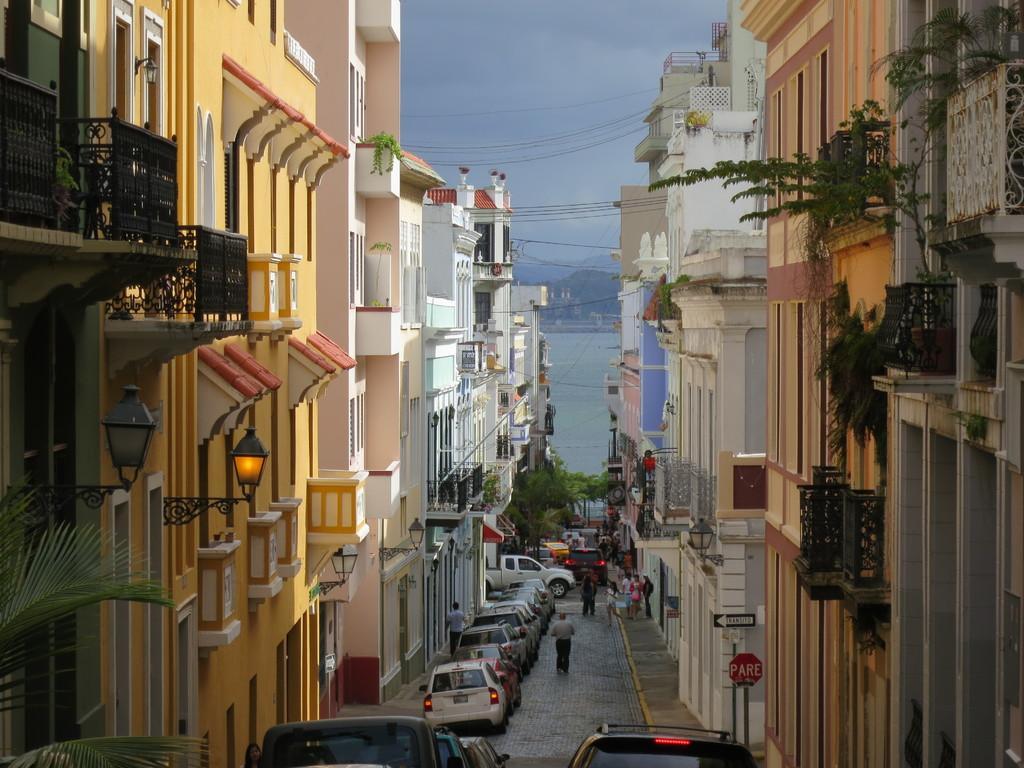Please provide a concise description of this image. In this image there are buildings and there are cars, persons and in the background there is a sea and there are mountains. On the top in the center there are wires and on the buildings there are plants and there are lights. 